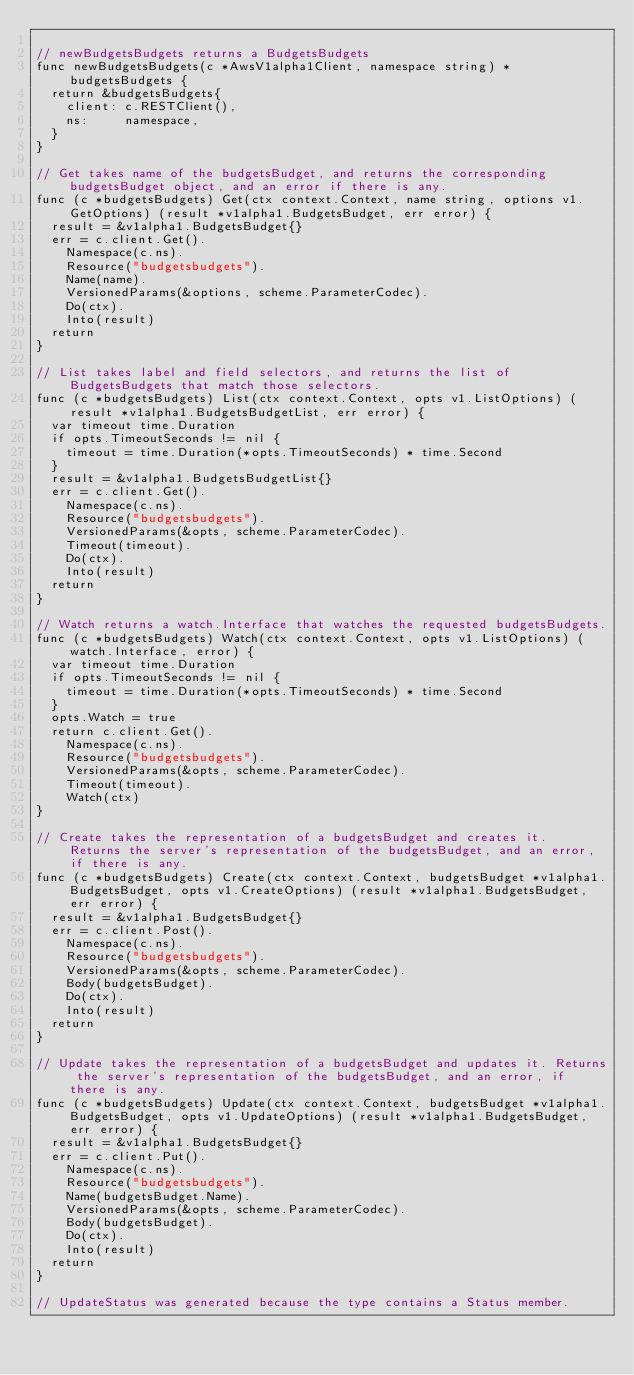<code> <loc_0><loc_0><loc_500><loc_500><_Go_>
// newBudgetsBudgets returns a BudgetsBudgets
func newBudgetsBudgets(c *AwsV1alpha1Client, namespace string) *budgetsBudgets {
	return &budgetsBudgets{
		client: c.RESTClient(),
		ns:     namespace,
	}
}

// Get takes name of the budgetsBudget, and returns the corresponding budgetsBudget object, and an error if there is any.
func (c *budgetsBudgets) Get(ctx context.Context, name string, options v1.GetOptions) (result *v1alpha1.BudgetsBudget, err error) {
	result = &v1alpha1.BudgetsBudget{}
	err = c.client.Get().
		Namespace(c.ns).
		Resource("budgetsbudgets").
		Name(name).
		VersionedParams(&options, scheme.ParameterCodec).
		Do(ctx).
		Into(result)
	return
}

// List takes label and field selectors, and returns the list of BudgetsBudgets that match those selectors.
func (c *budgetsBudgets) List(ctx context.Context, opts v1.ListOptions) (result *v1alpha1.BudgetsBudgetList, err error) {
	var timeout time.Duration
	if opts.TimeoutSeconds != nil {
		timeout = time.Duration(*opts.TimeoutSeconds) * time.Second
	}
	result = &v1alpha1.BudgetsBudgetList{}
	err = c.client.Get().
		Namespace(c.ns).
		Resource("budgetsbudgets").
		VersionedParams(&opts, scheme.ParameterCodec).
		Timeout(timeout).
		Do(ctx).
		Into(result)
	return
}

// Watch returns a watch.Interface that watches the requested budgetsBudgets.
func (c *budgetsBudgets) Watch(ctx context.Context, opts v1.ListOptions) (watch.Interface, error) {
	var timeout time.Duration
	if opts.TimeoutSeconds != nil {
		timeout = time.Duration(*opts.TimeoutSeconds) * time.Second
	}
	opts.Watch = true
	return c.client.Get().
		Namespace(c.ns).
		Resource("budgetsbudgets").
		VersionedParams(&opts, scheme.ParameterCodec).
		Timeout(timeout).
		Watch(ctx)
}

// Create takes the representation of a budgetsBudget and creates it.  Returns the server's representation of the budgetsBudget, and an error, if there is any.
func (c *budgetsBudgets) Create(ctx context.Context, budgetsBudget *v1alpha1.BudgetsBudget, opts v1.CreateOptions) (result *v1alpha1.BudgetsBudget, err error) {
	result = &v1alpha1.BudgetsBudget{}
	err = c.client.Post().
		Namespace(c.ns).
		Resource("budgetsbudgets").
		VersionedParams(&opts, scheme.ParameterCodec).
		Body(budgetsBudget).
		Do(ctx).
		Into(result)
	return
}

// Update takes the representation of a budgetsBudget and updates it. Returns the server's representation of the budgetsBudget, and an error, if there is any.
func (c *budgetsBudgets) Update(ctx context.Context, budgetsBudget *v1alpha1.BudgetsBudget, opts v1.UpdateOptions) (result *v1alpha1.BudgetsBudget, err error) {
	result = &v1alpha1.BudgetsBudget{}
	err = c.client.Put().
		Namespace(c.ns).
		Resource("budgetsbudgets").
		Name(budgetsBudget.Name).
		VersionedParams(&opts, scheme.ParameterCodec).
		Body(budgetsBudget).
		Do(ctx).
		Into(result)
	return
}

// UpdateStatus was generated because the type contains a Status member.</code> 